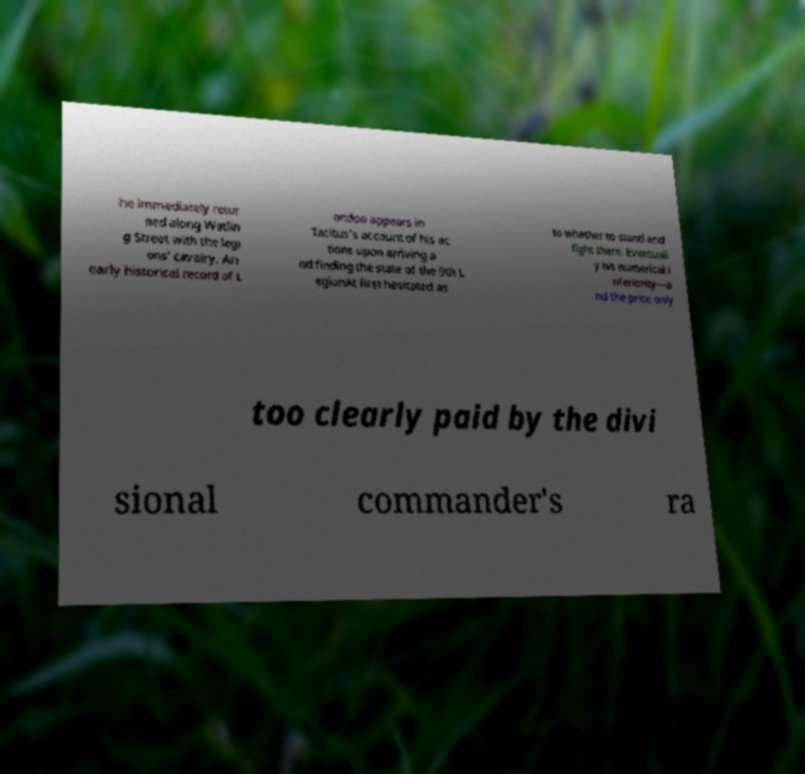Can you read and provide the text displayed in the image?This photo seems to have some interesting text. Can you extract and type it out for me? he immediately retur ned along Watlin g Street with the legi ons' cavalry. An early historical record of L ondon appears in Tacitus's account of his ac tions upon arriving a nd finding the state of the 9th L egionAt first hesitated as to whether to stand and fight there. Eventuall y his numerical i nferiority—a nd the price only too clearly paid by the divi sional commander's ra 